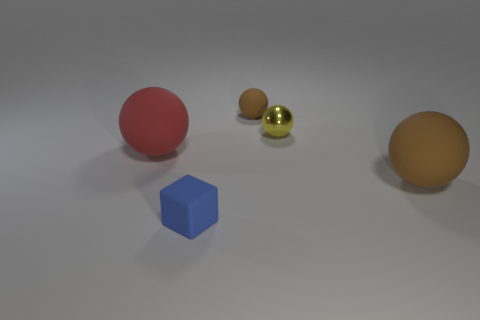What could be the purpose of arranging these objects in this way? This particular arrangement of objects may serve multiple purposes. It could be a display designed to study the effects of lighting and shadow on different colors and textures—a common exercise in 3D modeling and rendering. Alternatively, it might represent an artistic composition intended to evoke a sense of balance and asymmetry. The varying sizes, colors, and textures create visual interest and could suggest themes of diversity or individuality. 